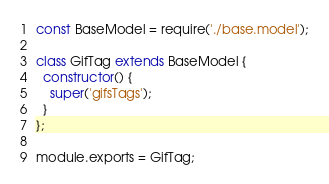<code> <loc_0><loc_0><loc_500><loc_500><_JavaScript_>const BaseModel = require('./base.model');

class GifTag extends BaseModel {
  constructor() {
    super('gifsTags');
  }
};

module.exports = GifTag;</code> 